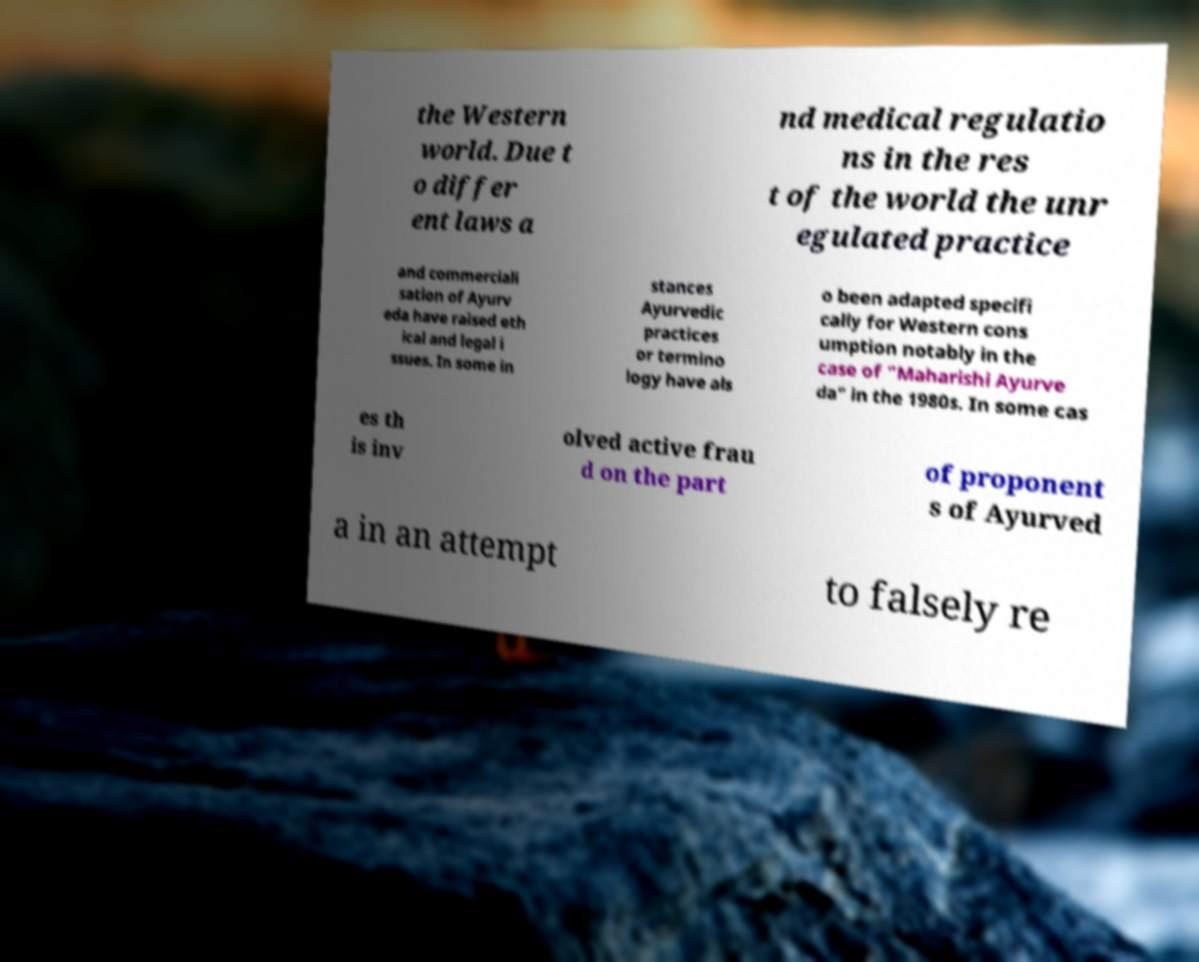For documentation purposes, I need the text within this image transcribed. Could you provide that? the Western world. Due t o differ ent laws a nd medical regulatio ns in the res t of the world the unr egulated practice and commerciali sation of Ayurv eda have raised eth ical and legal i ssues. In some in stances Ayurvedic practices or termino logy have als o been adapted specifi cally for Western cons umption notably in the case of "Maharishi Ayurve da" in the 1980s. In some cas es th is inv olved active frau d on the part of proponent s of Ayurved a in an attempt to falsely re 